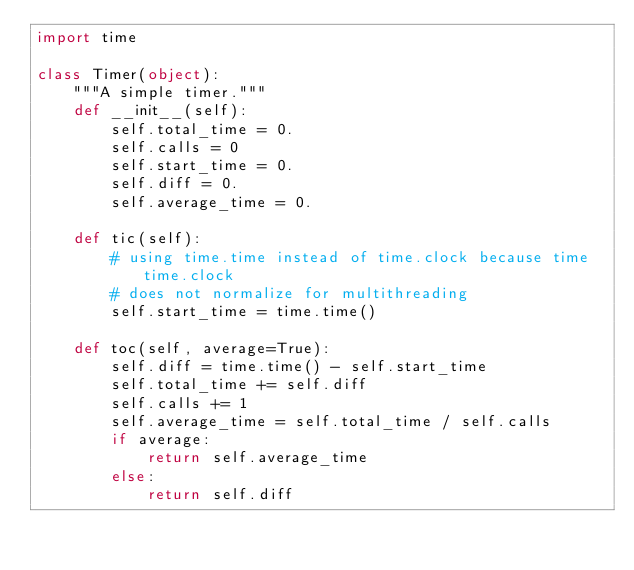Convert code to text. <code><loc_0><loc_0><loc_500><loc_500><_Python_>import time

class Timer(object):
    """A simple timer."""
    def __init__(self):
        self.total_time = 0.
        self.calls = 0
        self.start_time = 0.
        self.diff = 0.
        self.average_time = 0.

    def tic(self):
        # using time.time instead of time.clock because time time.clock
        # does not normalize for multithreading
        self.start_time = time.time()

    def toc(self, average=True):
        self.diff = time.time() - self.start_time
        self.total_time += self.diff
        self.calls += 1
        self.average_time = self.total_time / self.calls
        if average:
            return self.average_time
        else:
            return self.diff</code> 